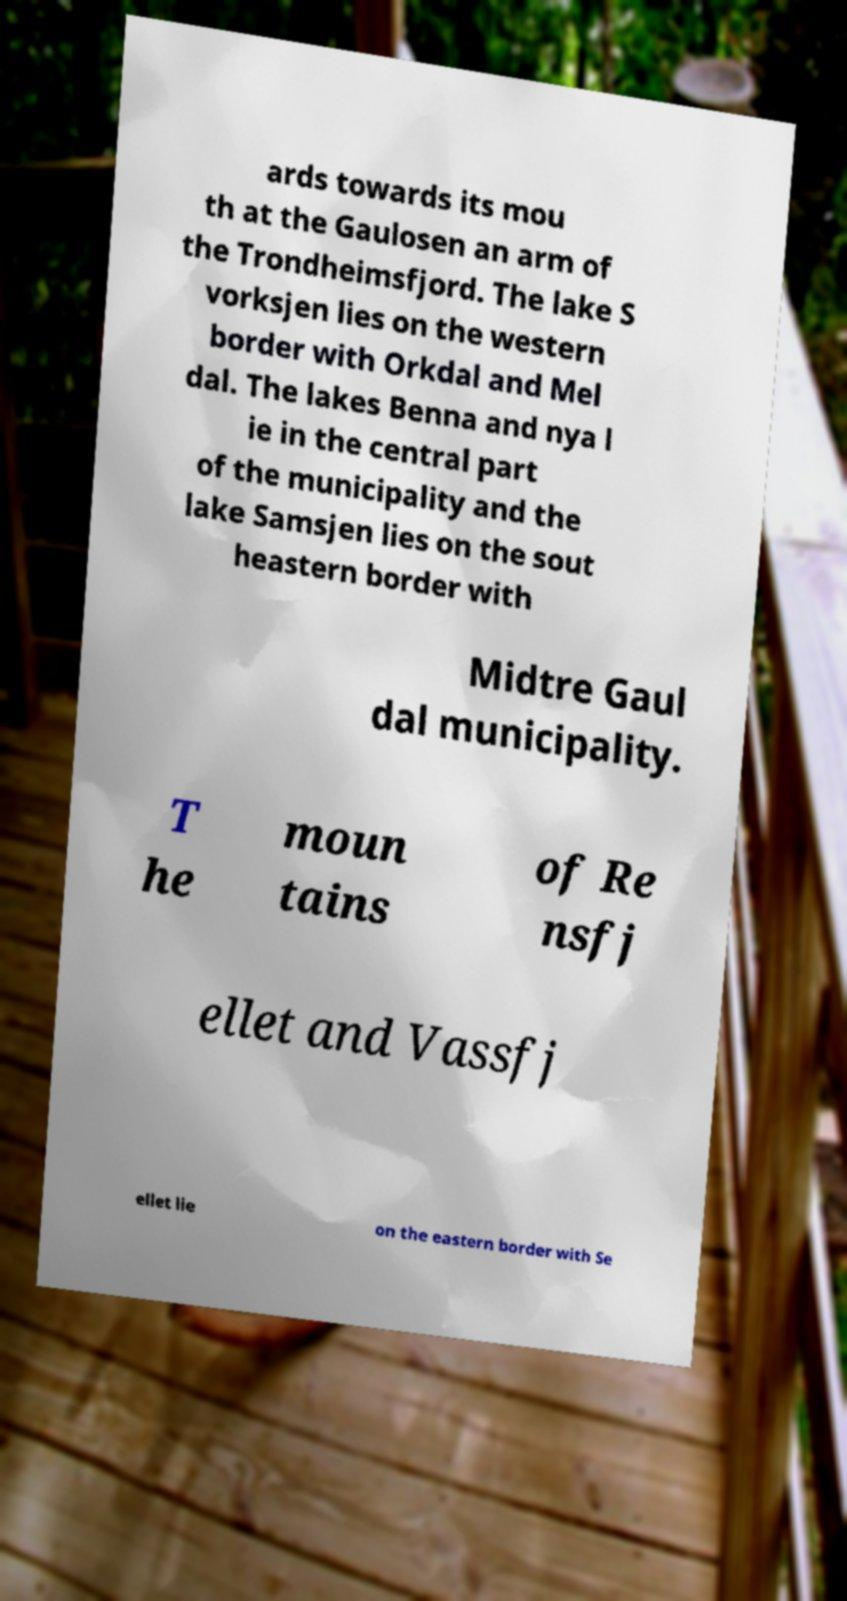Could you assist in decoding the text presented in this image and type it out clearly? ards towards its mou th at the Gaulosen an arm of the Trondheimsfjord. The lake S vorksjen lies on the western border with Orkdal and Mel dal. The lakes Benna and nya l ie in the central part of the municipality and the lake Samsjen lies on the sout heastern border with Midtre Gaul dal municipality. T he moun tains of Re nsfj ellet and Vassfj ellet lie on the eastern border with Se 